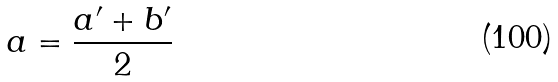Convert formula to latex. <formula><loc_0><loc_0><loc_500><loc_500>a = \frac { a ^ { \prime } + b ^ { \prime } } { 2 }</formula> 